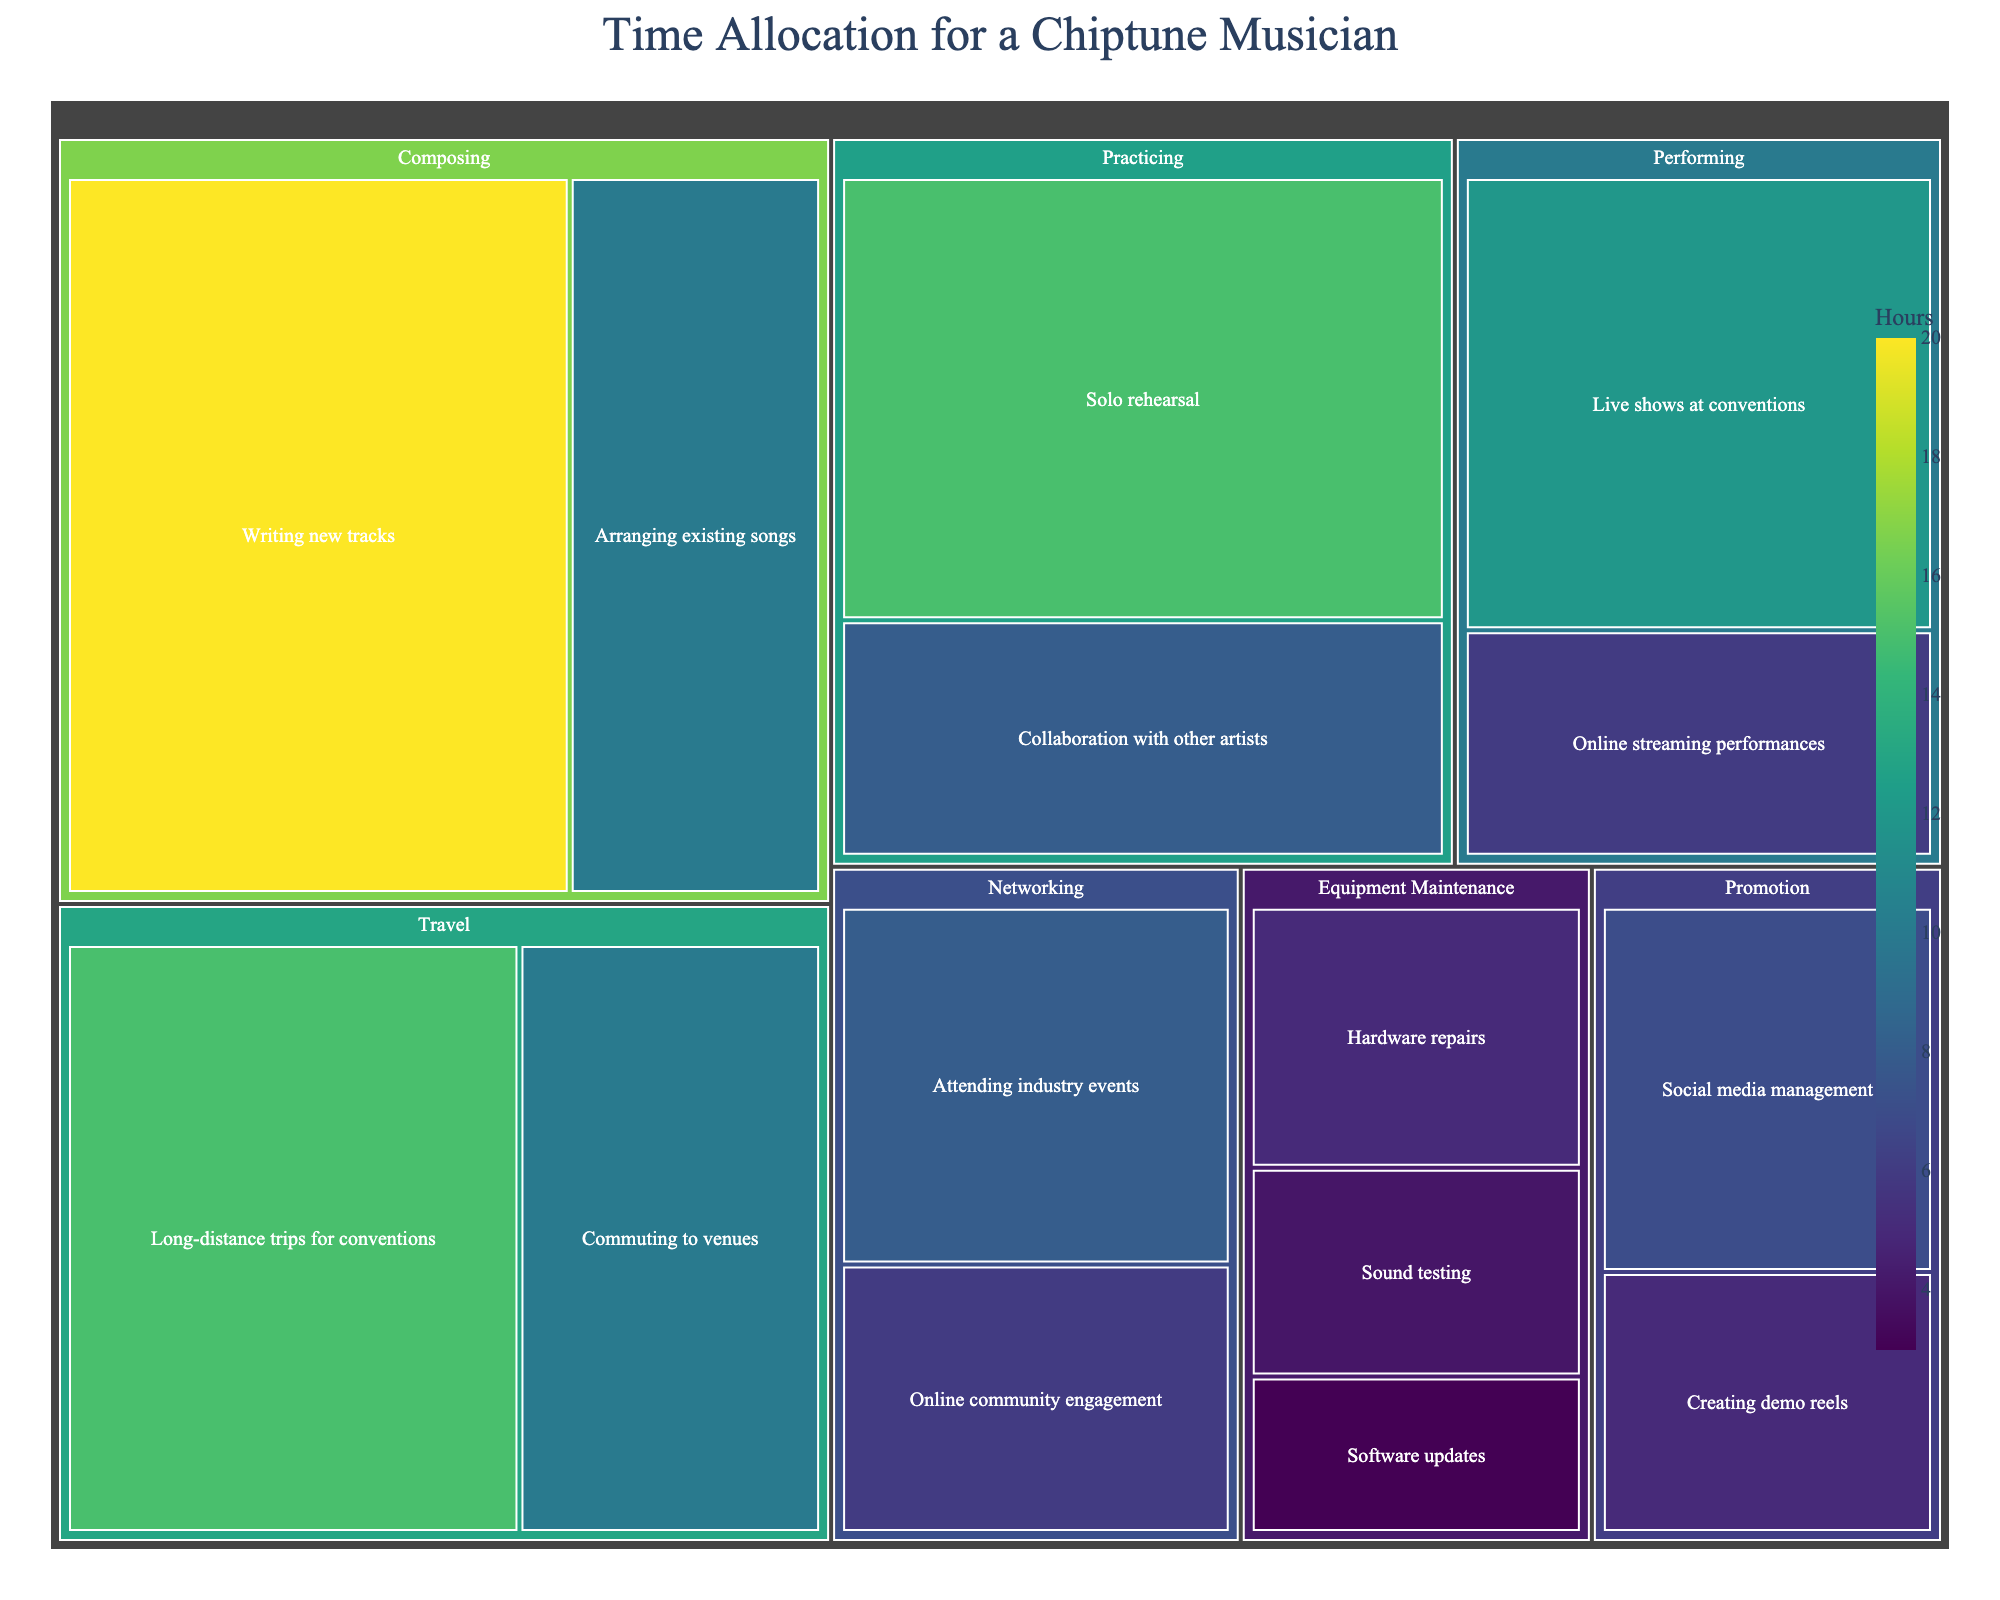What is the title of the plot? The title is prominently displayed at the top of the plot. It helps viewers understand what the visual represents.
Answer: Time Allocation for a Chiptune Musician Which category occupies the most hours? You need to visually compare the areas in the plot. The category with the largest area would represent the most hours.
Answer: Travel How many hours are spent on sound testing? By locating the 'Sound testing' subcategory within the 'Equipment Maintenance' category, you can read the value directly from the plot.
Answer: 4 What is the total time allocated to the Composing category? Sum the hours for 'Writing new tracks' and 'Arranging existing songs'. 20 + 10 = 30
Answer: 30 What is the difference in hours between Solo rehearsal and Collaboration with other artists? Find both 'Solo rehearsal' and 'Collaboration with other artists' under the 'Practicing' category, then subtract their hours. 15 - 8 = 7
Answer: 7 Which subcategory in the Networking category has fewer hours, and what is the difference? Compare 'Attending industry events' and 'Online community engagement'. 'Online community engagement' has fewer hours. 8 - 6 = 2
Answer: Online community engagement, 2 How does the time spent on Live shows at conventions compare to Online streaming performances? Compare ‘Live shows at conventions’ and ‘Online streaming performances’ under the 'Performing' category.
Answer: Live shows at conventions have more hours What is the total time spent on Equipment Maintenance? Sum the hours of all subcategories under 'Equipment Maintenance'. 5 + 3 + 4 = 12
Answer: 12 What is the proportion of hours spent on Writing new tracks compared to the total hours spent on Composing? The proportion is calculated by dividing the hours for 'Writing new tracks' by the total hours for 'Composing'. 20 / 30 = 2/3 or approximately 0.67
Answer: 0.67 What is the average time allocated across all subcategories? Sum all the hours and divide by the number of subcategories. (20+10+15+8+12+6+5+3+4+7+5+8+6+10+15) / 15 = 134 / 15 ≈ 8.93
Answer: 8.93 